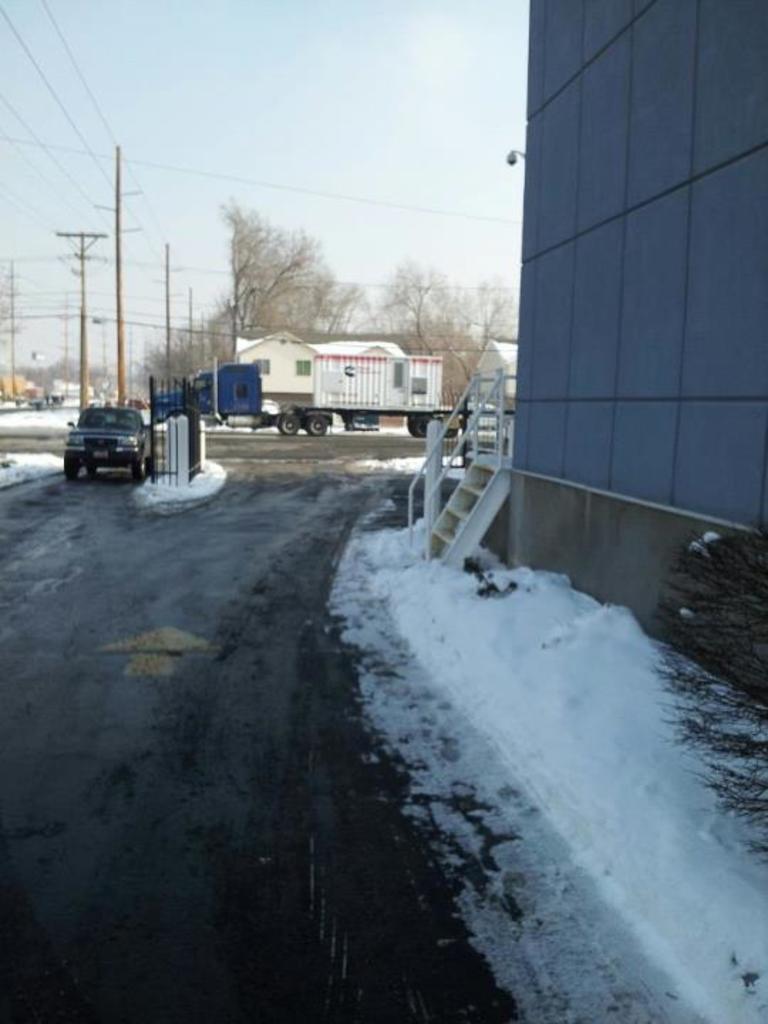In one or two sentences, can you explain what this image depicts? In this picture we can see vehicles on the road, wall, snow, poles, trees, some objects and in the background we can see the sky. 